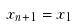<formula> <loc_0><loc_0><loc_500><loc_500>x _ { n + 1 } = x _ { 1 }</formula> 